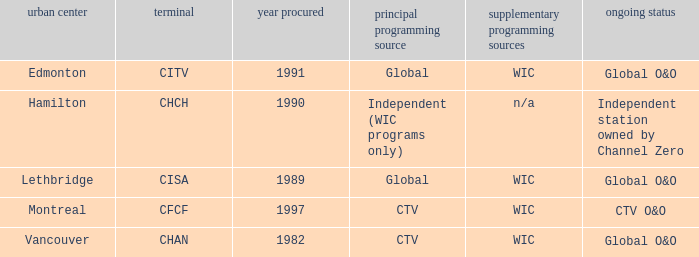Where is citv located Edmonton. Parse the full table. {'header': ['urban center', 'terminal', 'year procured', 'principal programming source', 'supplementary programming sources', 'ongoing status'], 'rows': [['Edmonton', 'CITV', '1991', 'Global', 'WIC', 'Global O&O'], ['Hamilton', 'CHCH', '1990', 'Independent (WIC programs only)', 'n/a', 'Independent station owned by Channel Zero'], ['Lethbridge', 'CISA', '1989', 'Global', 'WIC', 'Global O&O'], ['Montreal', 'CFCF', '1997', 'CTV', 'WIC', 'CTV O&O'], ['Vancouver', 'CHAN', '1982', 'CTV', 'WIC', 'Global O&O']]} 